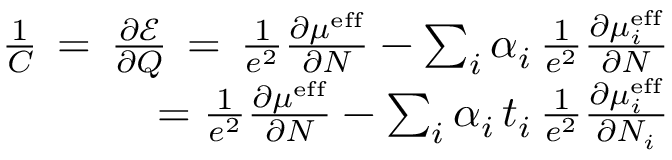Convert formula to latex. <formula><loc_0><loc_0><loc_500><loc_500>\begin{array} { r } { \frac { 1 } { C } \, = \, \frac { \partial \mathcal { E } } { \partial Q } \, = \, \frac { 1 } { e ^ { 2 } } \frac { \partial \mu ^ { e f f } } { \partial N } - \sum _ { i } \alpha _ { i } \, \frac { 1 } { e ^ { 2 } } \frac { \partial \mu _ { i } ^ { e f f } } { \partial N } } \\ { = \frac { 1 } { e ^ { 2 } } \frac { \partial \mu ^ { e f f } } { \partial N } - \sum _ { i } \alpha _ { i } \, t _ { i } \, \frac { 1 } { e ^ { 2 } } \frac { \partial \mu _ { i } ^ { e f f } } { \partial N _ { i } } } \end{array}</formula> 